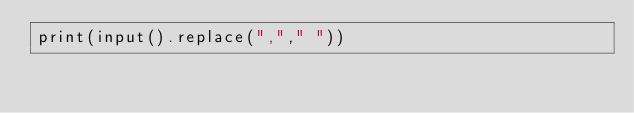<code> <loc_0><loc_0><loc_500><loc_500><_Python_>print(input().replace(","," "))</code> 